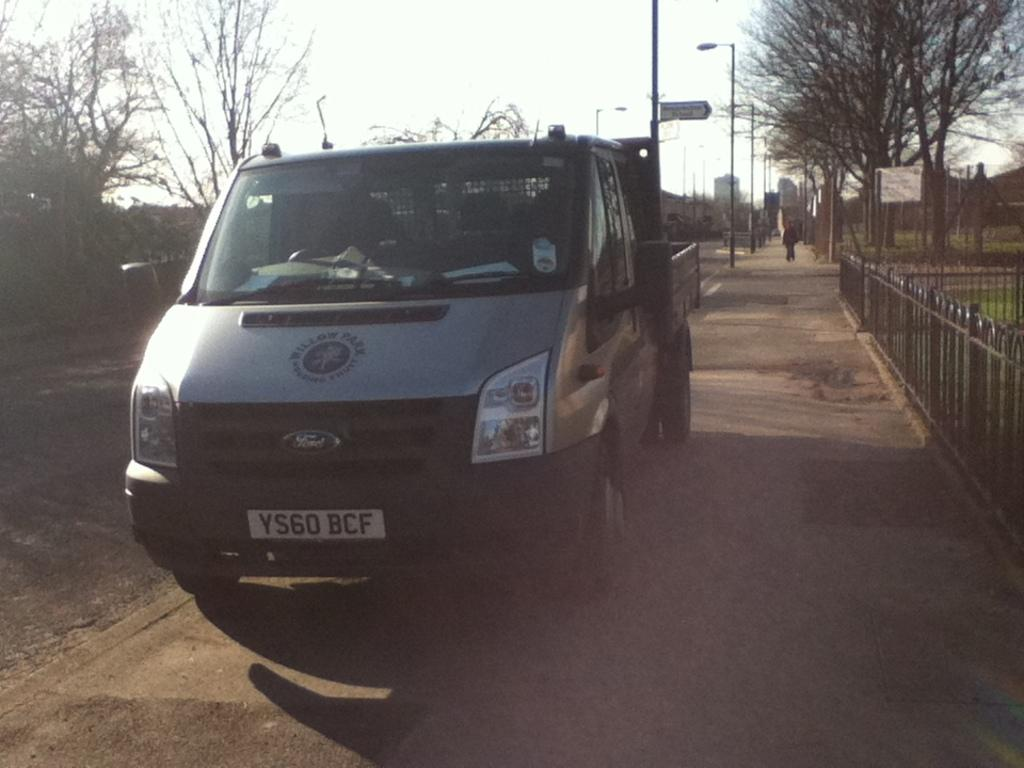What type of vehicle is in the image? There is a gray-colored vehicle in the image. What can be seen in the background of the image? There are light poles and trees in the background of the image. What is the color of the sky in the image? The sky is visible in the image, and it appears to be in white color. What type of game is being played on the vehicle in the image? There is no game being played on the vehicle in the image. What color are the trousers of the person sitting in the vehicle? There is no person sitting in the vehicle in the image, so we cannot determine the color of their trousers. 